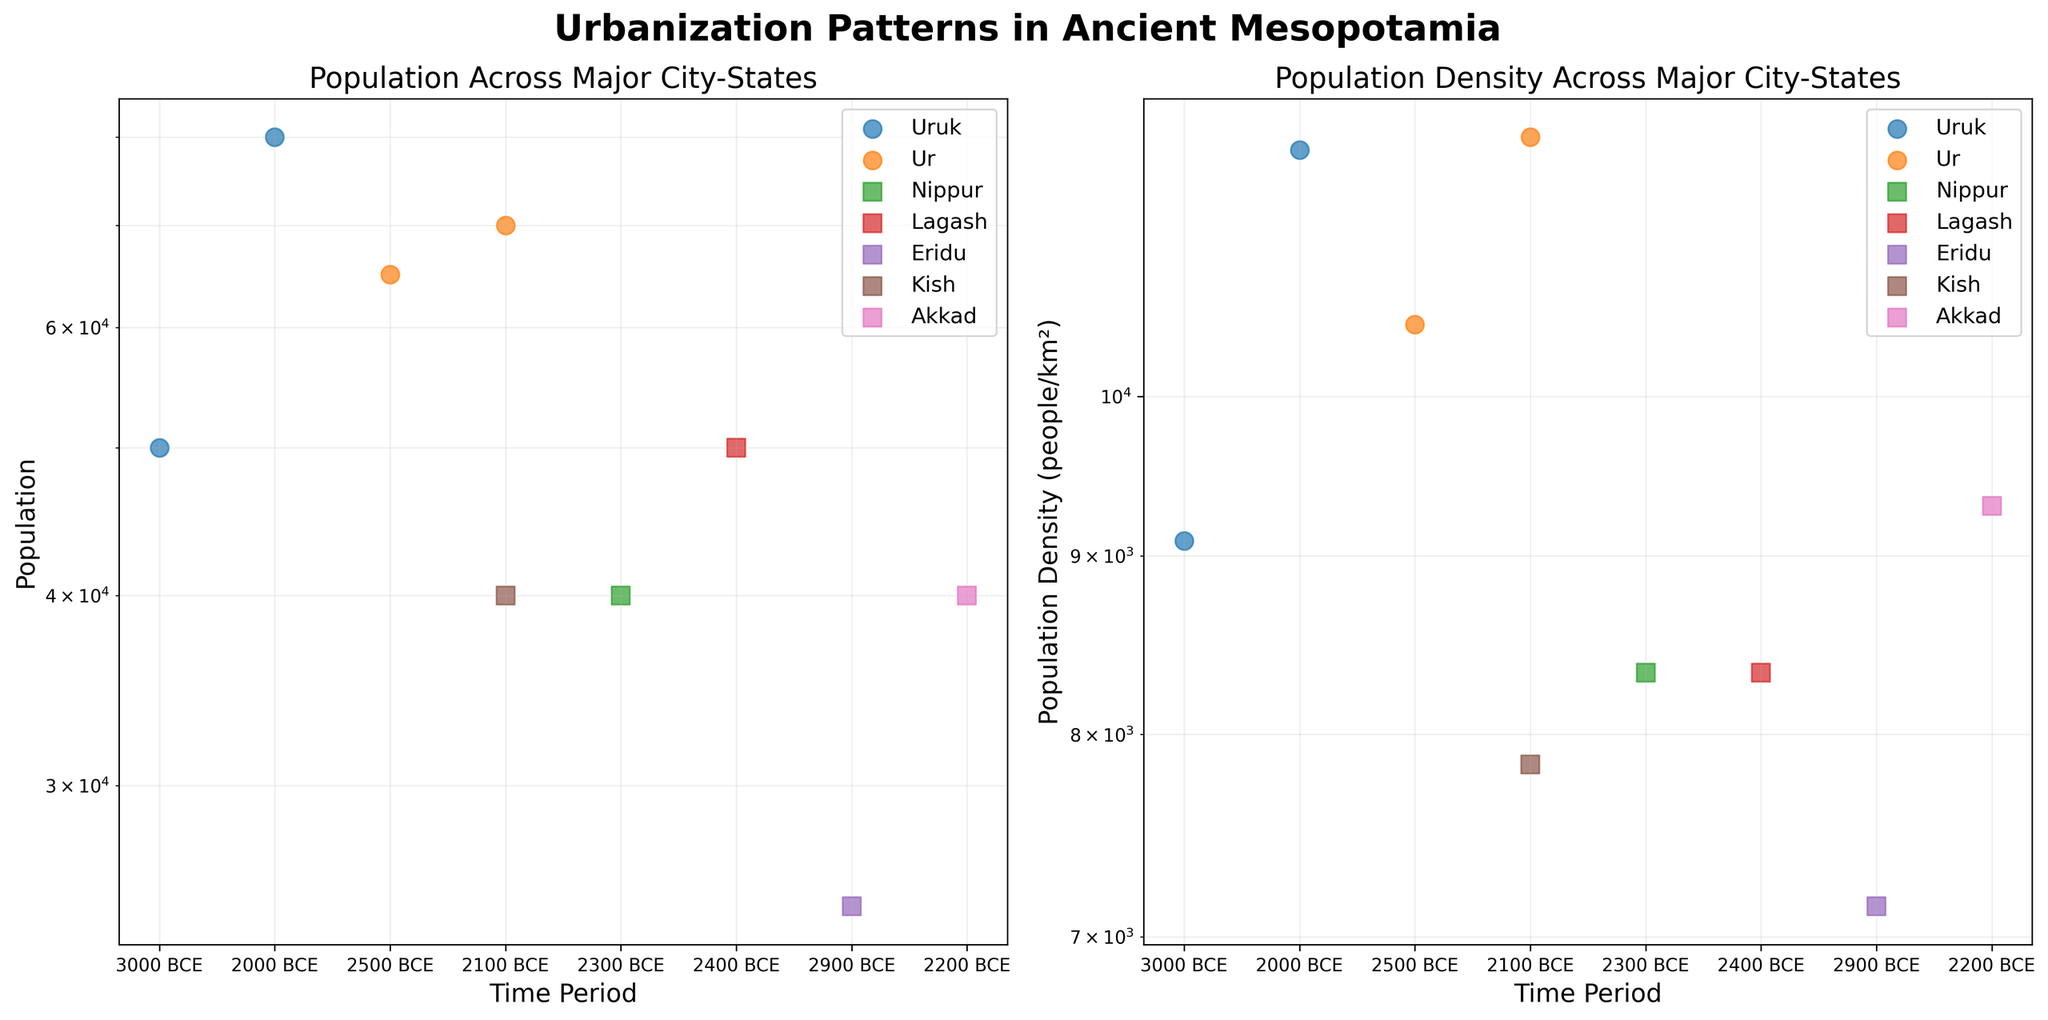What's the title of the figure? The title of a figure is typically placed at the top and provides a summary of what the figure depicts.
Answer: "Urbanization Patterns in Ancient Mesopotamia" What is the y-axis scale of the Population plot? The y-axis scale can be identified by looking at the tick labels and the presence of any indicators like "log". The Population plot y-axis is marked with powers of ten indicating a logarithmic scale.
Answer: Logarithmic Which city-state had the highest population density around 2000 BCE? To find the city-state with the highest population density, locate the points around 2000 BCE on the Population Density plot and compare their positions on the y-axis.
Answer: Uruk How does the population trend of Ur compare to that of Uruk over time? Examining the Population plot, track the scatter points for both Ur and Uruk over the range of time periods. Note the general direction of points for each city-state.
Answer: Both Ur and Uruk show an increasing population trend over time Which city-state has the smallest population density around 2100 BCE? To determine the city-state with the smallest population density at 2100 BCE, look at the points around that year on the Population Density plot and identify the lowest point.
Answer: Kish How does the population density of Nippur compare to Lagash around 2300 BCE? Identify the points for Nippur and Lagash around 2300 BCE in the Population Density plot and compare their y-axis values.
Answer: Nippur has a higher population density than Lagash around 2300 BCE Which city-state shows the most significant change in population between the earliest and latest recorded times? Look for the city-state with the greatest vertical distance between its lowest and highest points on the Population plot.
Answer: Uruk What can be observed about the population density of Akkad in the dataset? To observe the population density of Akkad, look at all points corresponding to Akkad in the Population Density plot.
Answer: Akkad has a consistent population density around 9300 people/km² Between 2400 BCE and 2200 BCE, which city’s population density increased the most? Compare approximated values for different city-states between 2400 BCE and 2200 BCE in the Population Density plot.
Answer: Uruk What characteristic is shared by the markers representing Ur in both the plots? Notice the marker types for Ur in both the Population and Population Density plots.
Answer: They are both circles 